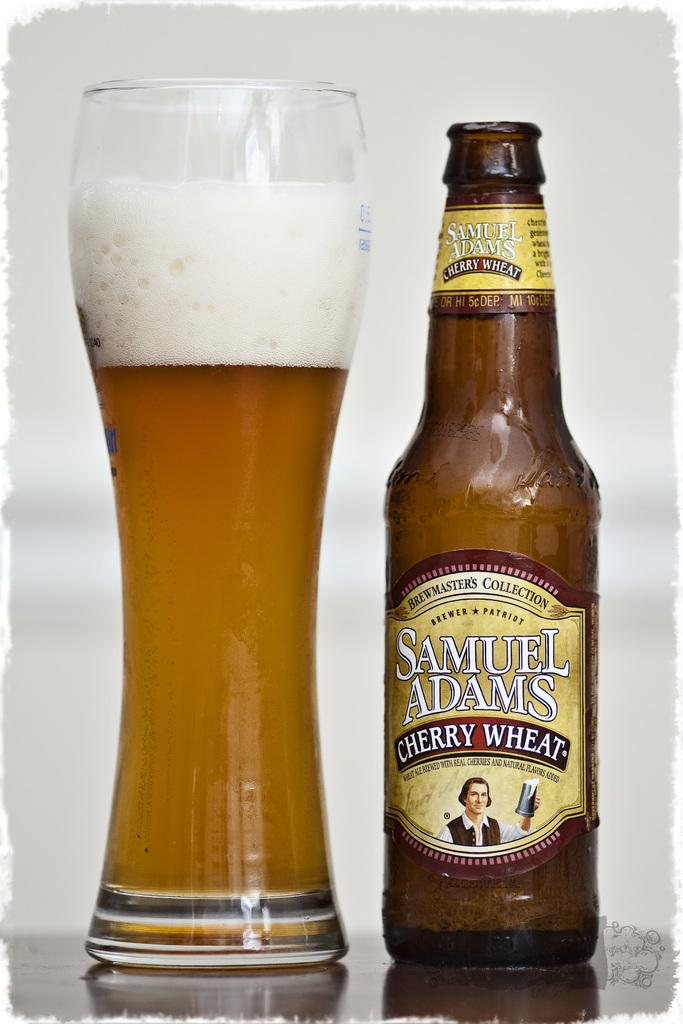<image>
Summarize the visual content of the image. Bottle with a label that says Samuel Adams next to a cup of beer. 